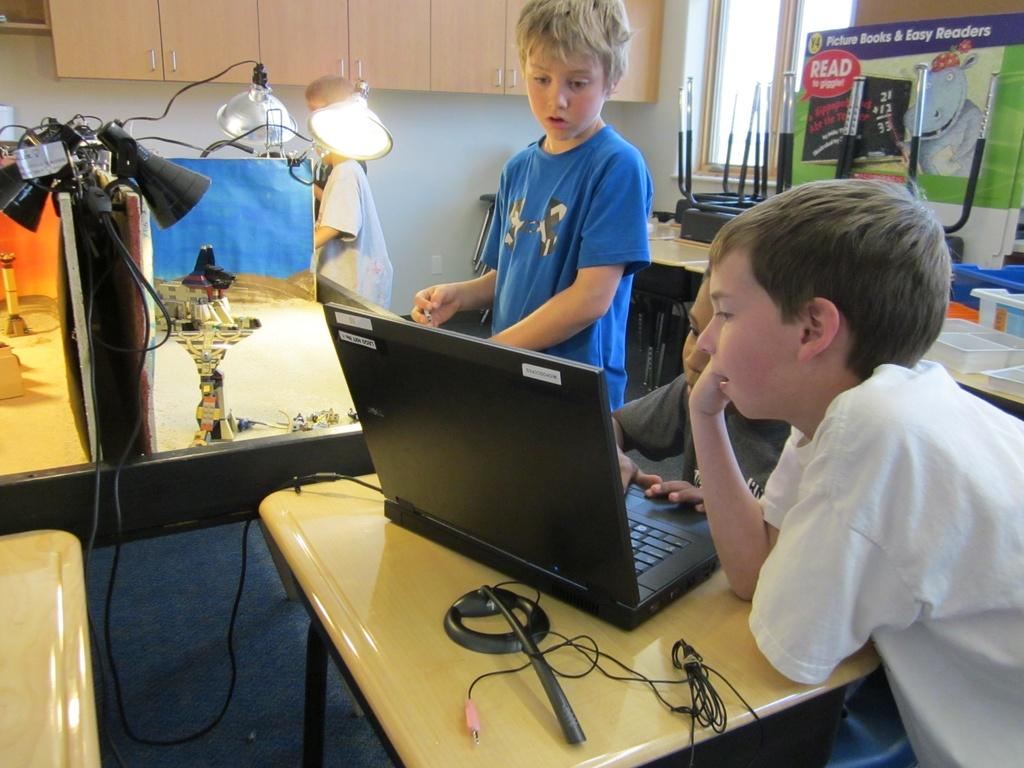<image>
Provide a brief description of the given image. A sign behind two kids is about picture books and easy readers. 